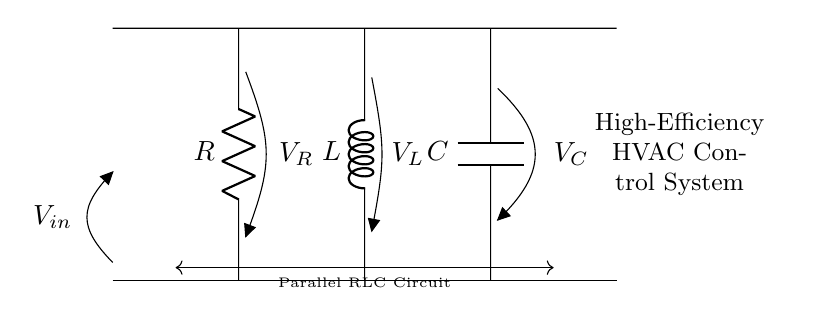What are the components in this circuit? The circuit includes a resistor, an inductor, and a capacitor, which can be identified from the labels R, L, and C respectively.
Answer: Resistor, Inductor, Capacitor What is the type of this circuit? This is a parallel RLC circuit, which can be recognized by the arrangement of the resistor, inductor, and capacitor connected in parallel between the same two nodes.
Answer: Parallel RLC Circuit What does the input voltage represent? The input voltage, labeled as V_in, represents the voltage supplied to the parallel RLC circuit, and is indicated on the left side of the diagram.
Answer: V_in How many components are in the circuit? There are three components: one resistor, one inductor, and one capacitor.
Answer: Three What is the voltage across the resistor? The voltage across the resistor is labeled V_R, which directly indicates its value as the voltage drop across that component when currents flow.
Answer: V_R What is the significance of having a parallel configuration for RLC circuits? A parallel configuration allows each component to operate independently at the same voltage, which can enhance voltage control, improve stability, and provide better frequency response in high-efficiency systems like HVAC.
Answer: Independent operation How does the current flow in this circuit? Current flows through all three branches (R, L, and C) simultaneously, and their total current is the sum of the individual branch currents due to the parallel configuration.
Answer: Simultaneously through R, L, and C 